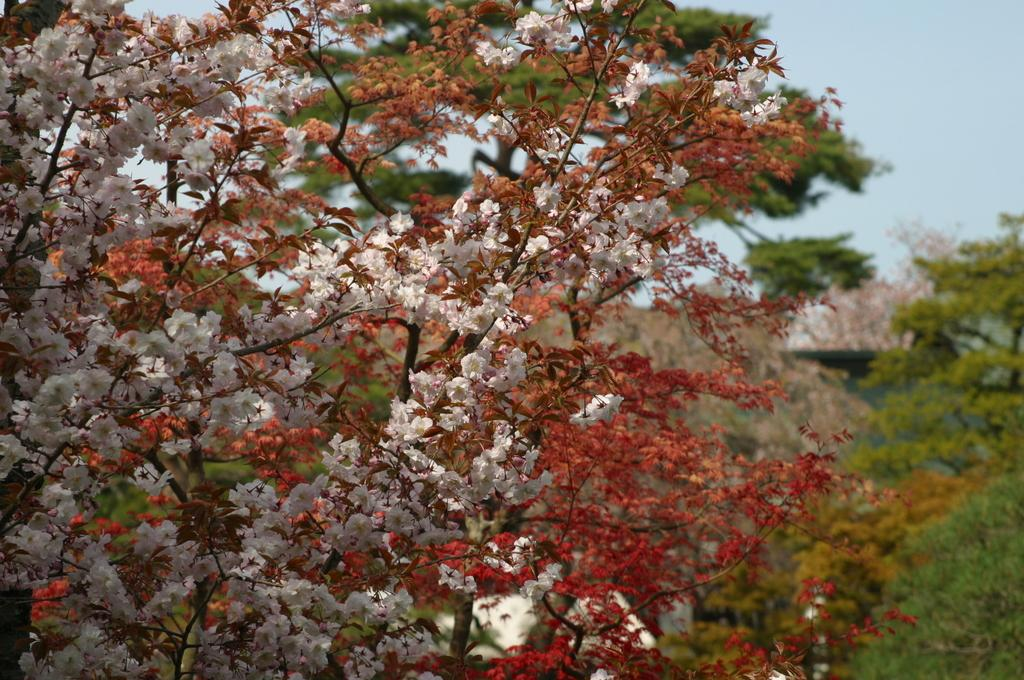What types of plants can be seen in the image? There are different types of trees in the image. What color flowers are on the trees? The trees have red and white color flowers. How many trees can be seen in the background of the image? There are many other trees in the background of the image. What is the condition of the sky in the image? The sky is clear in the image. Can you see a turkey wearing a crown in the image? No, there is no turkey or crown present in the image. The image features different types of trees with red and white flowers, and a clear sky in the background. 